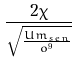Convert formula to latex. <formula><loc_0><loc_0><loc_500><loc_500>\frac { 2 \chi } { \sqrt { \frac { U m _ { s e n } } { o ^ { 9 } } } }</formula> 